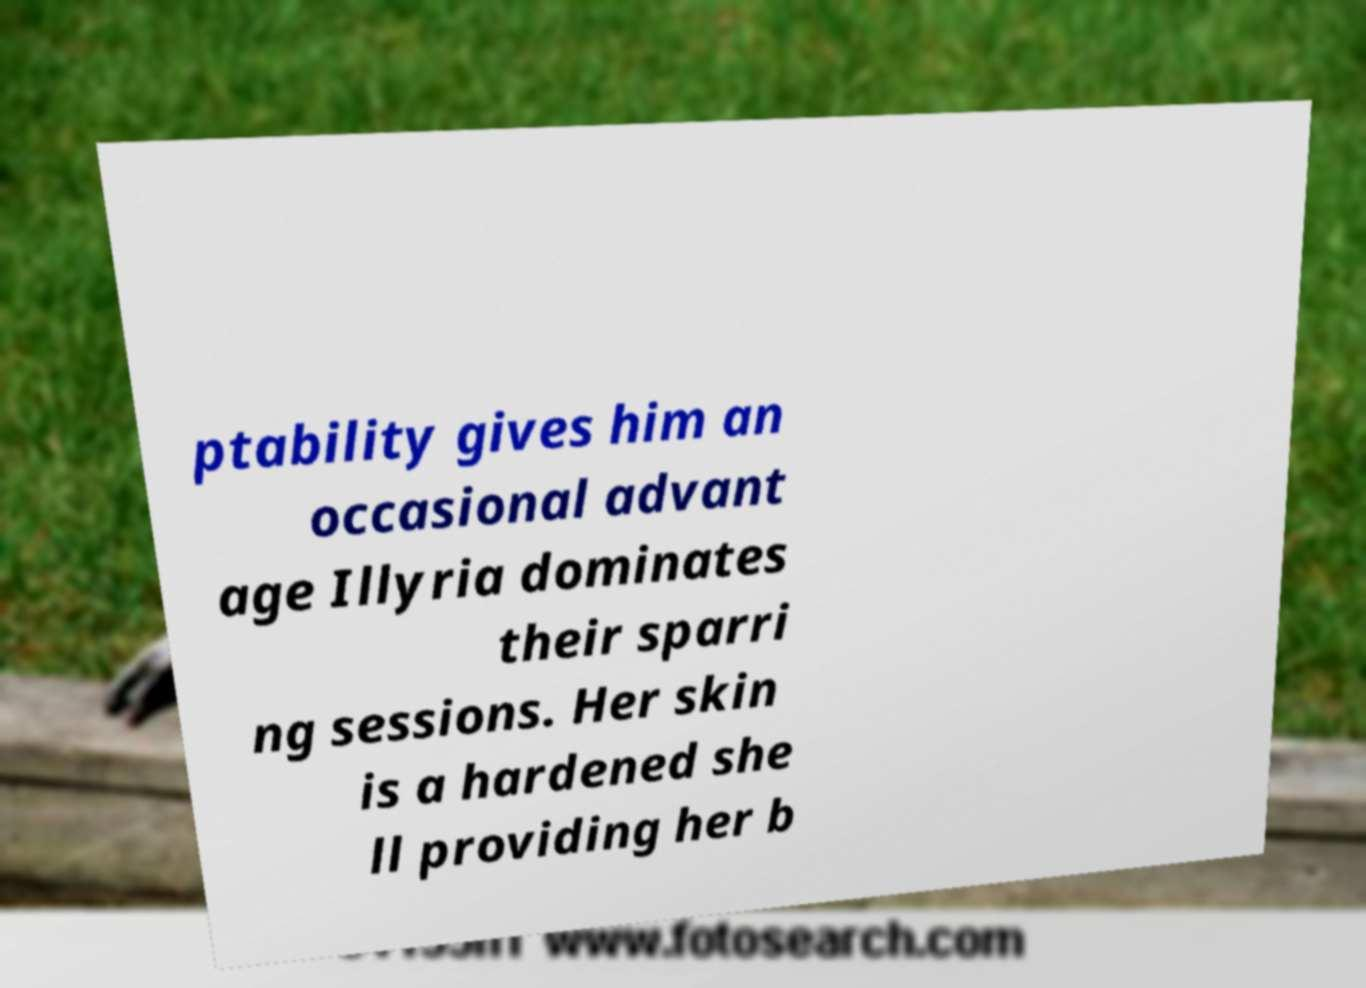Please read and relay the text visible in this image. What does it say? ptability gives him an occasional advant age Illyria dominates their sparri ng sessions. Her skin is a hardened she ll providing her b 